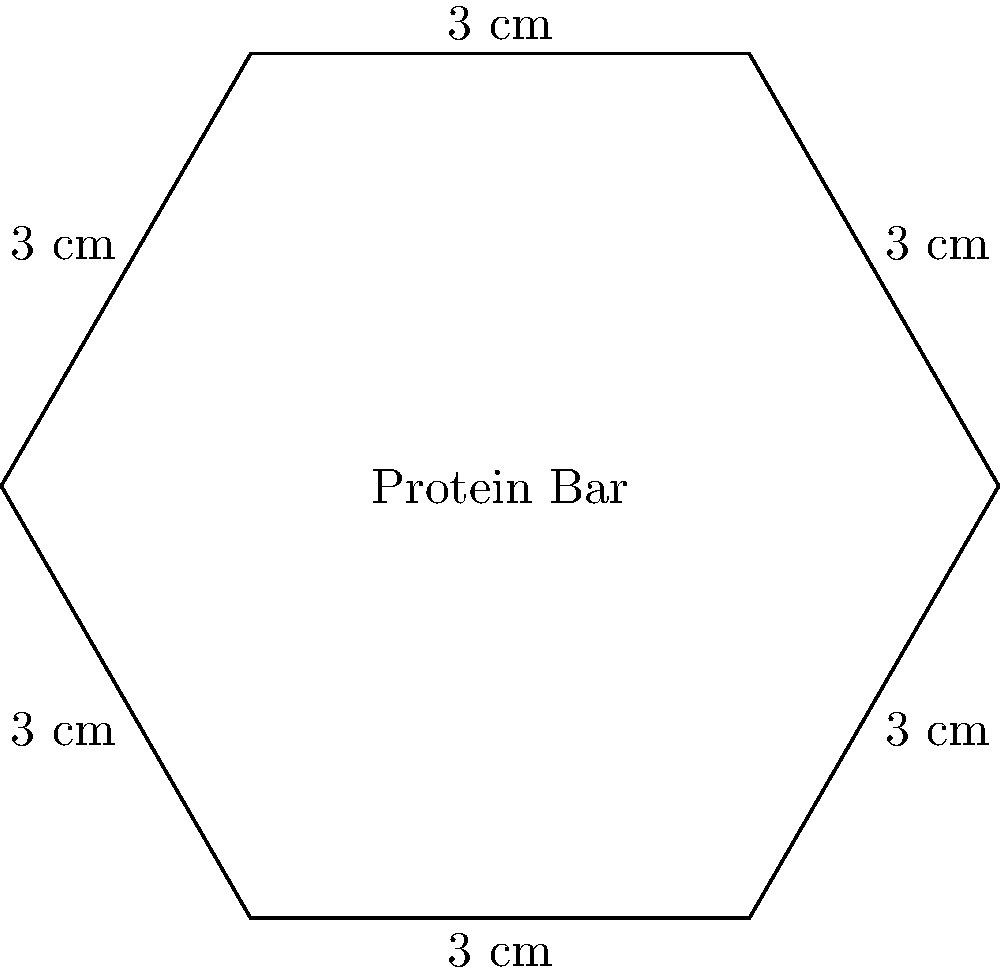A new health-conscious protein bar comes in a hexagonal package. If each side of the hexagonal package measures 3 cm, what is the perimeter of the package? To find the perimeter of the hexagonal protein bar package, we need to follow these steps:

1. Identify the shape: The package is a regular hexagon (all sides are equal).

2. Count the number of sides: A hexagon has 6 sides.

3. Note the length of each side: Each side measures 3 cm.

4. Calculate the perimeter: 
   The perimeter is the sum of all side lengths.
   
   Perimeter = Number of sides × Length of one side
              = $6 \times 3$ cm
              = $18$ cm

Therefore, the perimeter of the hexagonal protein bar package is 18 cm.
Answer: $18$ cm 